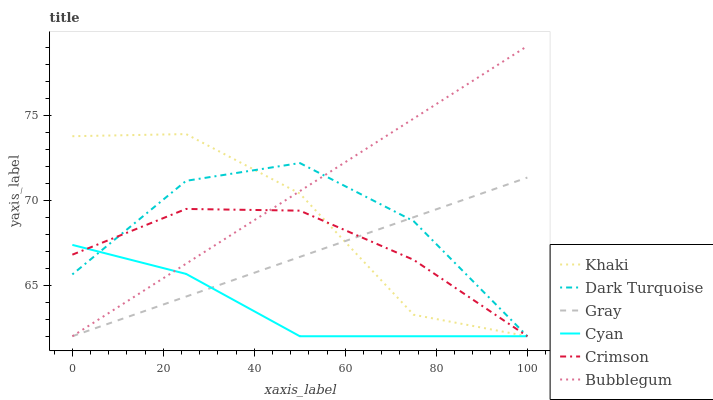Does Cyan have the minimum area under the curve?
Answer yes or no. Yes. Does Bubblegum have the maximum area under the curve?
Answer yes or no. Yes. Does Khaki have the minimum area under the curve?
Answer yes or no. No. Does Khaki have the maximum area under the curve?
Answer yes or no. No. Is Gray the smoothest?
Answer yes or no. Yes. Is Khaki the roughest?
Answer yes or no. Yes. Is Dark Turquoise the smoothest?
Answer yes or no. No. Is Dark Turquoise the roughest?
Answer yes or no. No. Does Khaki have the highest value?
Answer yes or no. No. 